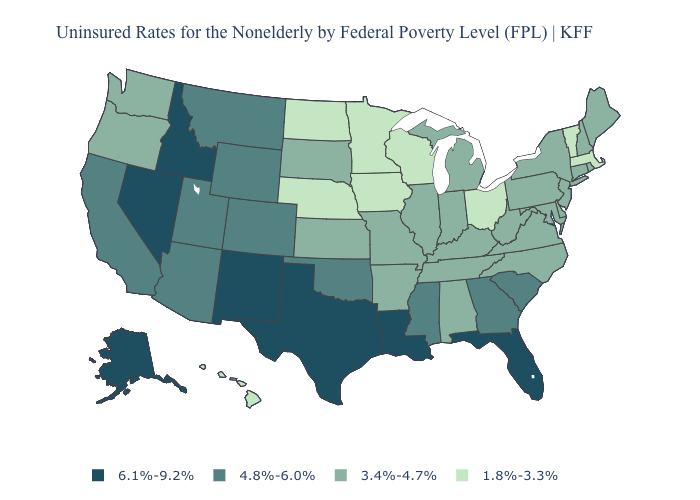Name the states that have a value in the range 4.8%-6.0%?
Be succinct. Arizona, California, Colorado, Georgia, Mississippi, Montana, Oklahoma, South Carolina, Utah, Wyoming. Is the legend a continuous bar?
Short answer required. No. Among the states that border Florida , which have the highest value?
Concise answer only. Georgia. What is the value of Georgia?
Concise answer only. 4.8%-6.0%. Name the states that have a value in the range 3.4%-4.7%?
Be succinct. Alabama, Arkansas, Connecticut, Delaware, Illinois, Indiana, Kansas, Kentucky, Maine, Maryland, Michigan, Missouri, New Hampshire, New Jersey, New York, North Carolina, Oregon, Pennsylvania, Rhode Island, South Dakota, Tennessee, Virginia, Washington, West Virginia. Does the first symbol in the legend represent the smallest category?
Quick response, please. No. Which states have the highest value in the USA?
Answer briefly. Alaska, Florida, Idaho, Louisiana, Nevada, New Mexico, Texas. Name the states that have a value in the range 6.1%-9.2%?
Answer briefly. Alaska, Florida, Idaho, Louisiana, Nevada, New Mexico, Texas. What is the value of New York?
Quick response, please. 3.4%-4.7%. How many symbols are there in the legend?
Be succinct. 4. Does Alaska have the highest value in the USA?
Write a very short answer. Yes. Which states have the highest value in the USA?
Concise answer only. Alaska, Florida, Idaho, Louisiana, Nevada, New Mexico, Texas. Which states have the lowest value in the USA?
Give a very brief answer. Hawaii, Iowa, Massachusetts, Minnesota, Nebraska, North Dakota, Ohio, Vermont, Wisconsin. Does Vermont have the highest value in the Northeast?
Give a very brief answer. No. Does the map have missing data?
Keep it brief. No. 